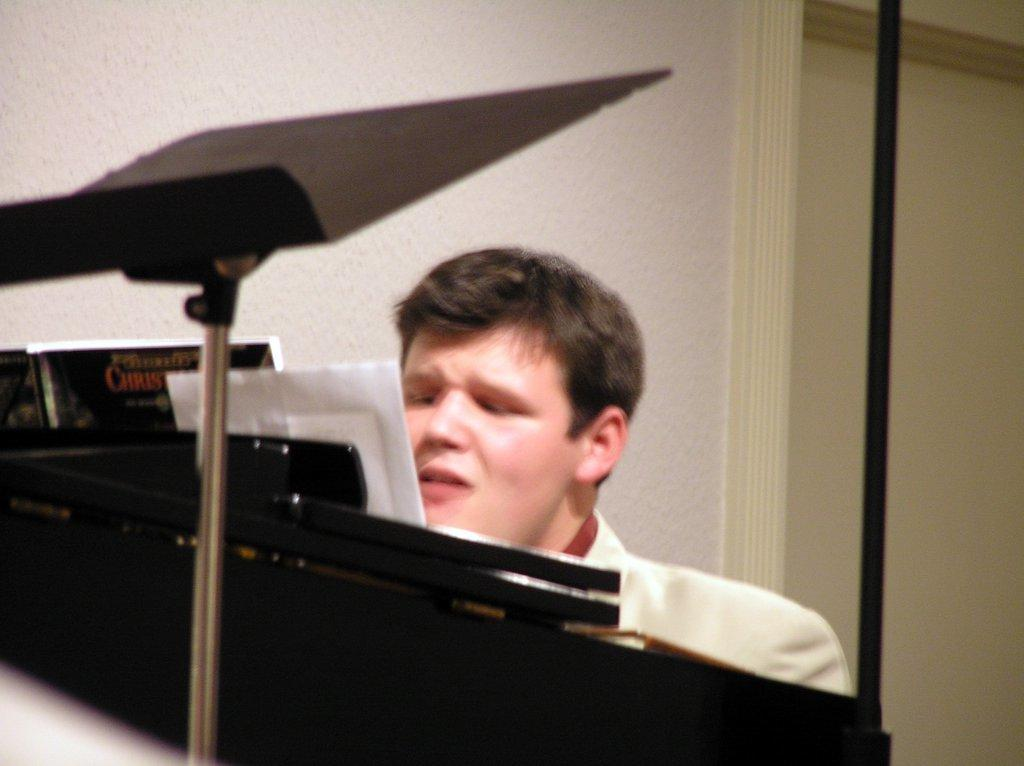Who is present in the image? There is a man in the image. What is the man doing in the image? The man is sitting in front of a piano. What can be seen behind the man? There is a wall behind the man. What type of twist can be seen in the man's hair in the image? There is no twist visible in the man's hair in the image, as his hair is not mentioned in the provided facts. 